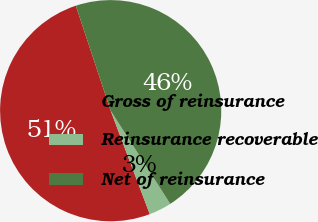<chart> <loc_0><loc_0><loc_500><loc_500><pie_chart><fcel>Gross of reinsurance<fcel>Reinsurance recoverable<fcel>Net of reinsurance<nl><fcel>50.65%<fcel>3.3%<fcel>46.05%<nl></chart> 